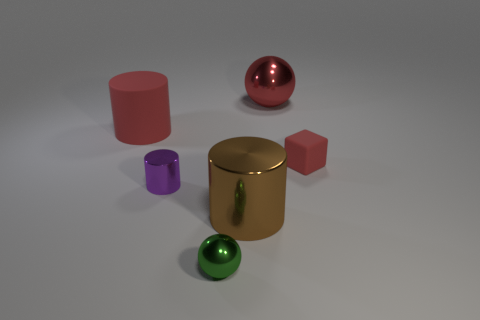How many other objects are there of the same size as the rubber block?
Keep it short and to the point. 2. The large red object left of the ball on the left side of the shiny ball that is to the right of the green object is made of what material?
Make the answer very short. Rubber. Do the matte cube and the metallic thing behind the purple cylinder have the same size?
Your answer should be very brief. No. There is a red thing that is both left of the red block and right of the tiny green object; how big is it?
Provide a short and direct response. Large. Is there a metal thing that has the same color as the small shiny sphere?
Your answer should be very brief. No. What color is the shiny thing behind the matte cylinder that is to the left of the big red shiny thing?
Your answer should be compact. Red. Are there fewer red metal things in front of the purple thing than things behind the green sphere?
Give a very brief answer. Yes. Does the brown shiny object have the same size as the green metal thing?
Make the answer very short. No. What shape is the object that is both to the right of the large shiny cylinder and in front of the red rubber cylinder?
Keep it short and to the point. Cube. How many big cylinders are made of the same material as the tiny ball?
Your answer should be very brief. 1. 